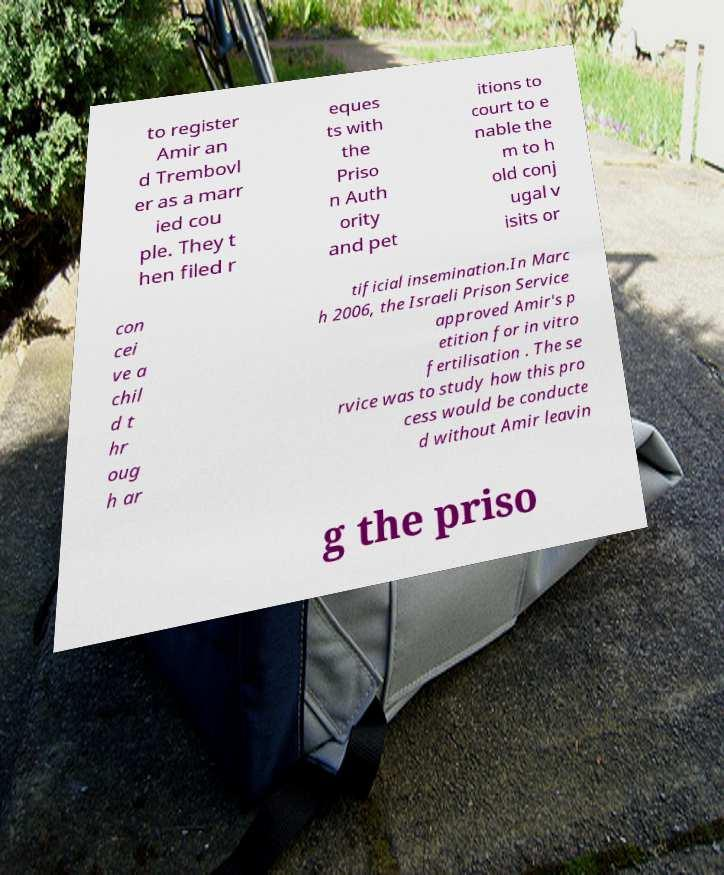I need the written content from this picture converted into text. Can you do that? to register Amir an d Trembovl er as a marr ied cou ple. They t hen filed r eques ts with the Priso n Auth ority and pet itions to court to e nable the m to h old conj ugal v isits or con cei ve a chil d t hr oug h ar tificial insemination.In Marc h 2006, the Israeli Prison Service approved Amir's p etition for in vitro fertilisation . The se rvice was to study how this pro cess would be conducte d without Amir leavin g the priso 